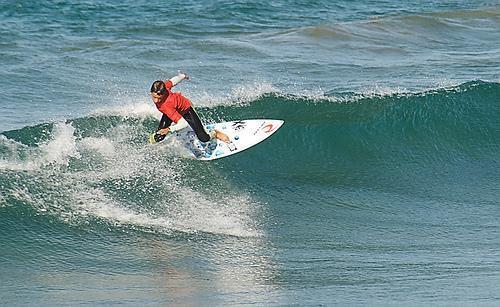How many people are surfboarding?
Give a very brief answer. 1. 